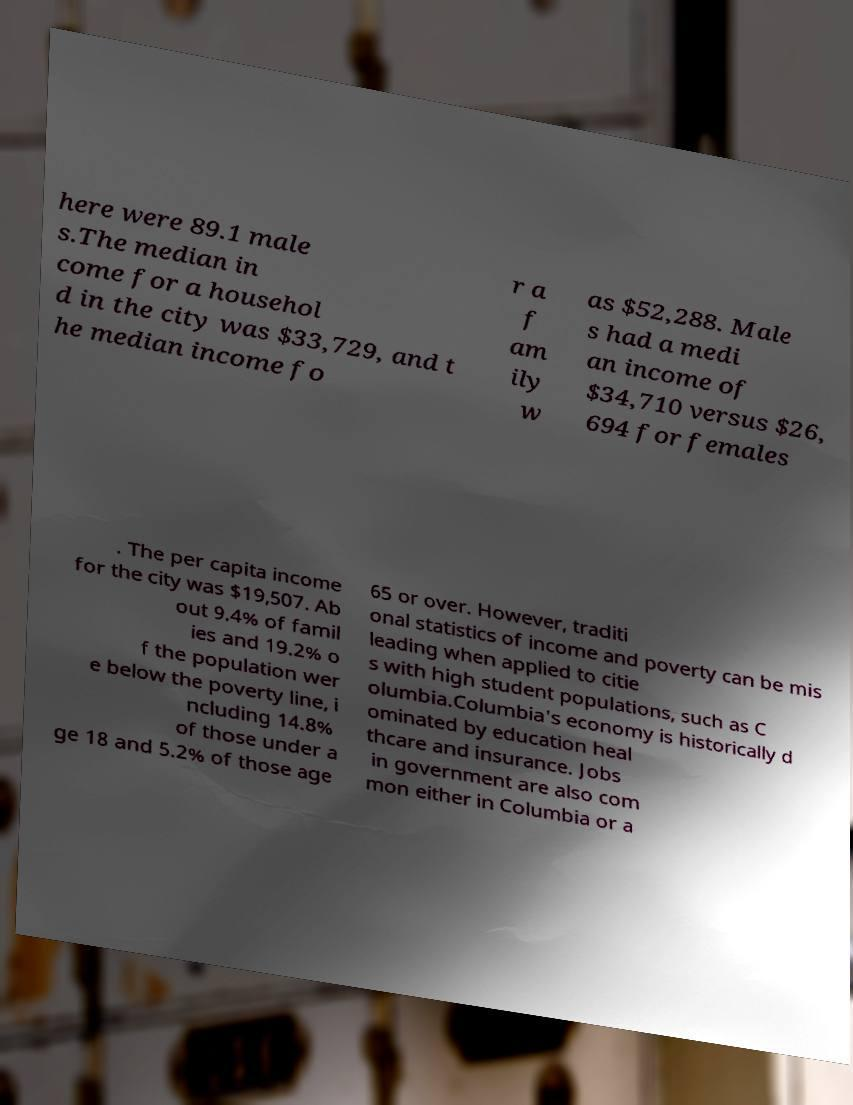What messages or text are displayed in this image? I need them in a readable, typed format. here were 89.1 male s.The median in come for a househol d in the city was $33,729, and t he median income fo r a f am ily w as $52,288. Male s had a medi an income of $34,710 versus $26, 694 for females . The per capita income for the city was $19,507. Ab out 9.4% of famil ies and 19.2% o f the population wer e below the poverty line, i ncluding 14.8% of those under a ge 18 and 5.2% of those age 65 or over. However, traditi onal statistics of income and poverty can be mis leading when applied to citie s with high student populations, such as C olumbia.Columbia's economy is historically d ominated by education heal thcare and insurance. Jobs in government are also com mon either in Columbia or a 